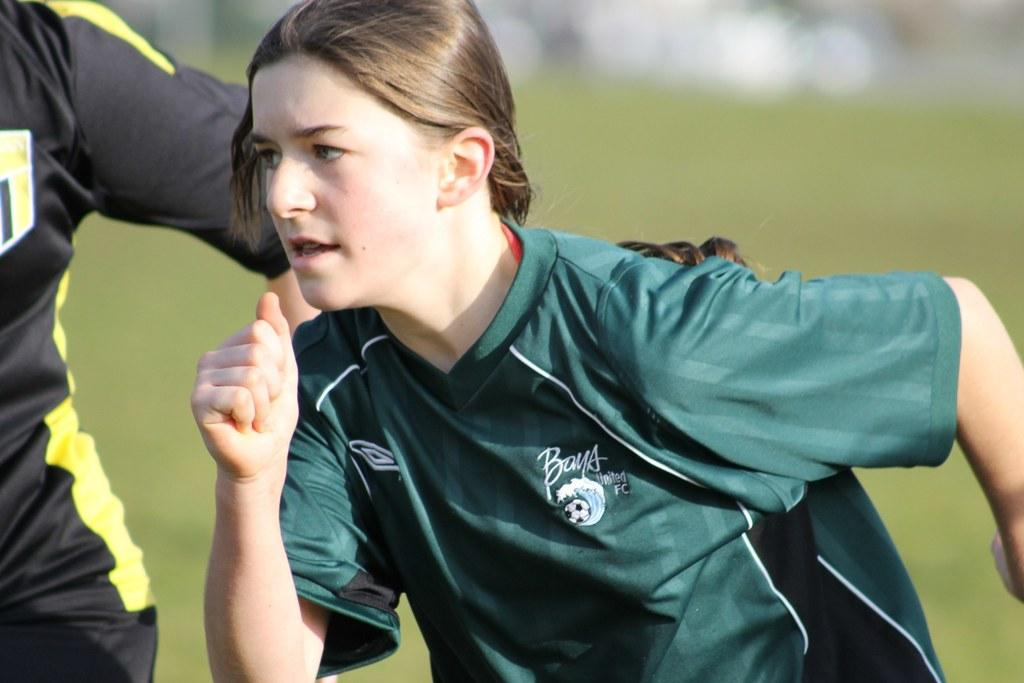How many people are in the image? There are two people in the image. What can be observed about the clothing of the people in the image? The people are wearing different color dresses color dresses. What colors are present in the background of the image? The background of the image is in green and white colors. How is the background of the image depicted? The background is blurred. How many jokes are being told by the people in the image? There is no indication in the image that the people are telling jokes, so it cannot be determined from the picture. 